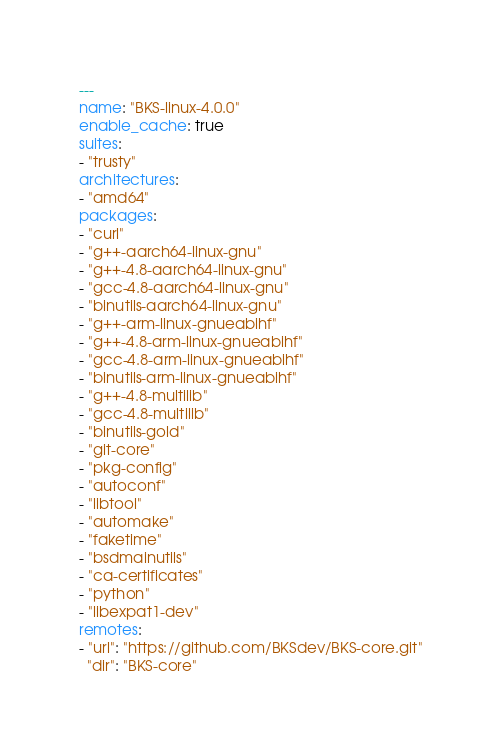<code> <loc_0><loc_0><loc_500><loc_500><_YAML_>---
name: "BKS-linux-4.0.0"
enable_cache: true
suites:
- "trusty"
architectures:
- "amd64"
packages:
- "curl"
- "g++-aarch64-linux-gnu"
- "g++-4.8-aarch64-linux-gnu"
- "gcc-4.8-aarch64-linux-gnu"
- "binutils-aarch64-linux-gnu"
- "g++-arm-linux-gnueabihf"
- "g++-4.8-arm-linux-gnueabihf"
- "gcc-4.8-arm-linux-gnueabihf"
- "binutils-arm-linux-gnueabihf"
- "g++-4.8-multilib"
- "gcc-4.8-multilib"
- "binutils-gold"
- "git-core"
- "pkg-config"
- "autoconf"
- "libtool"
- "automake"
- "faketime"
- "bsdmainutils"
- "ca-certificates"
- "python"
- "libexpat1-dev"
remotes:
- "url": "https://github.com/BKSdev/BKS-core.git"
  "dir": "BKS-core"</code> 